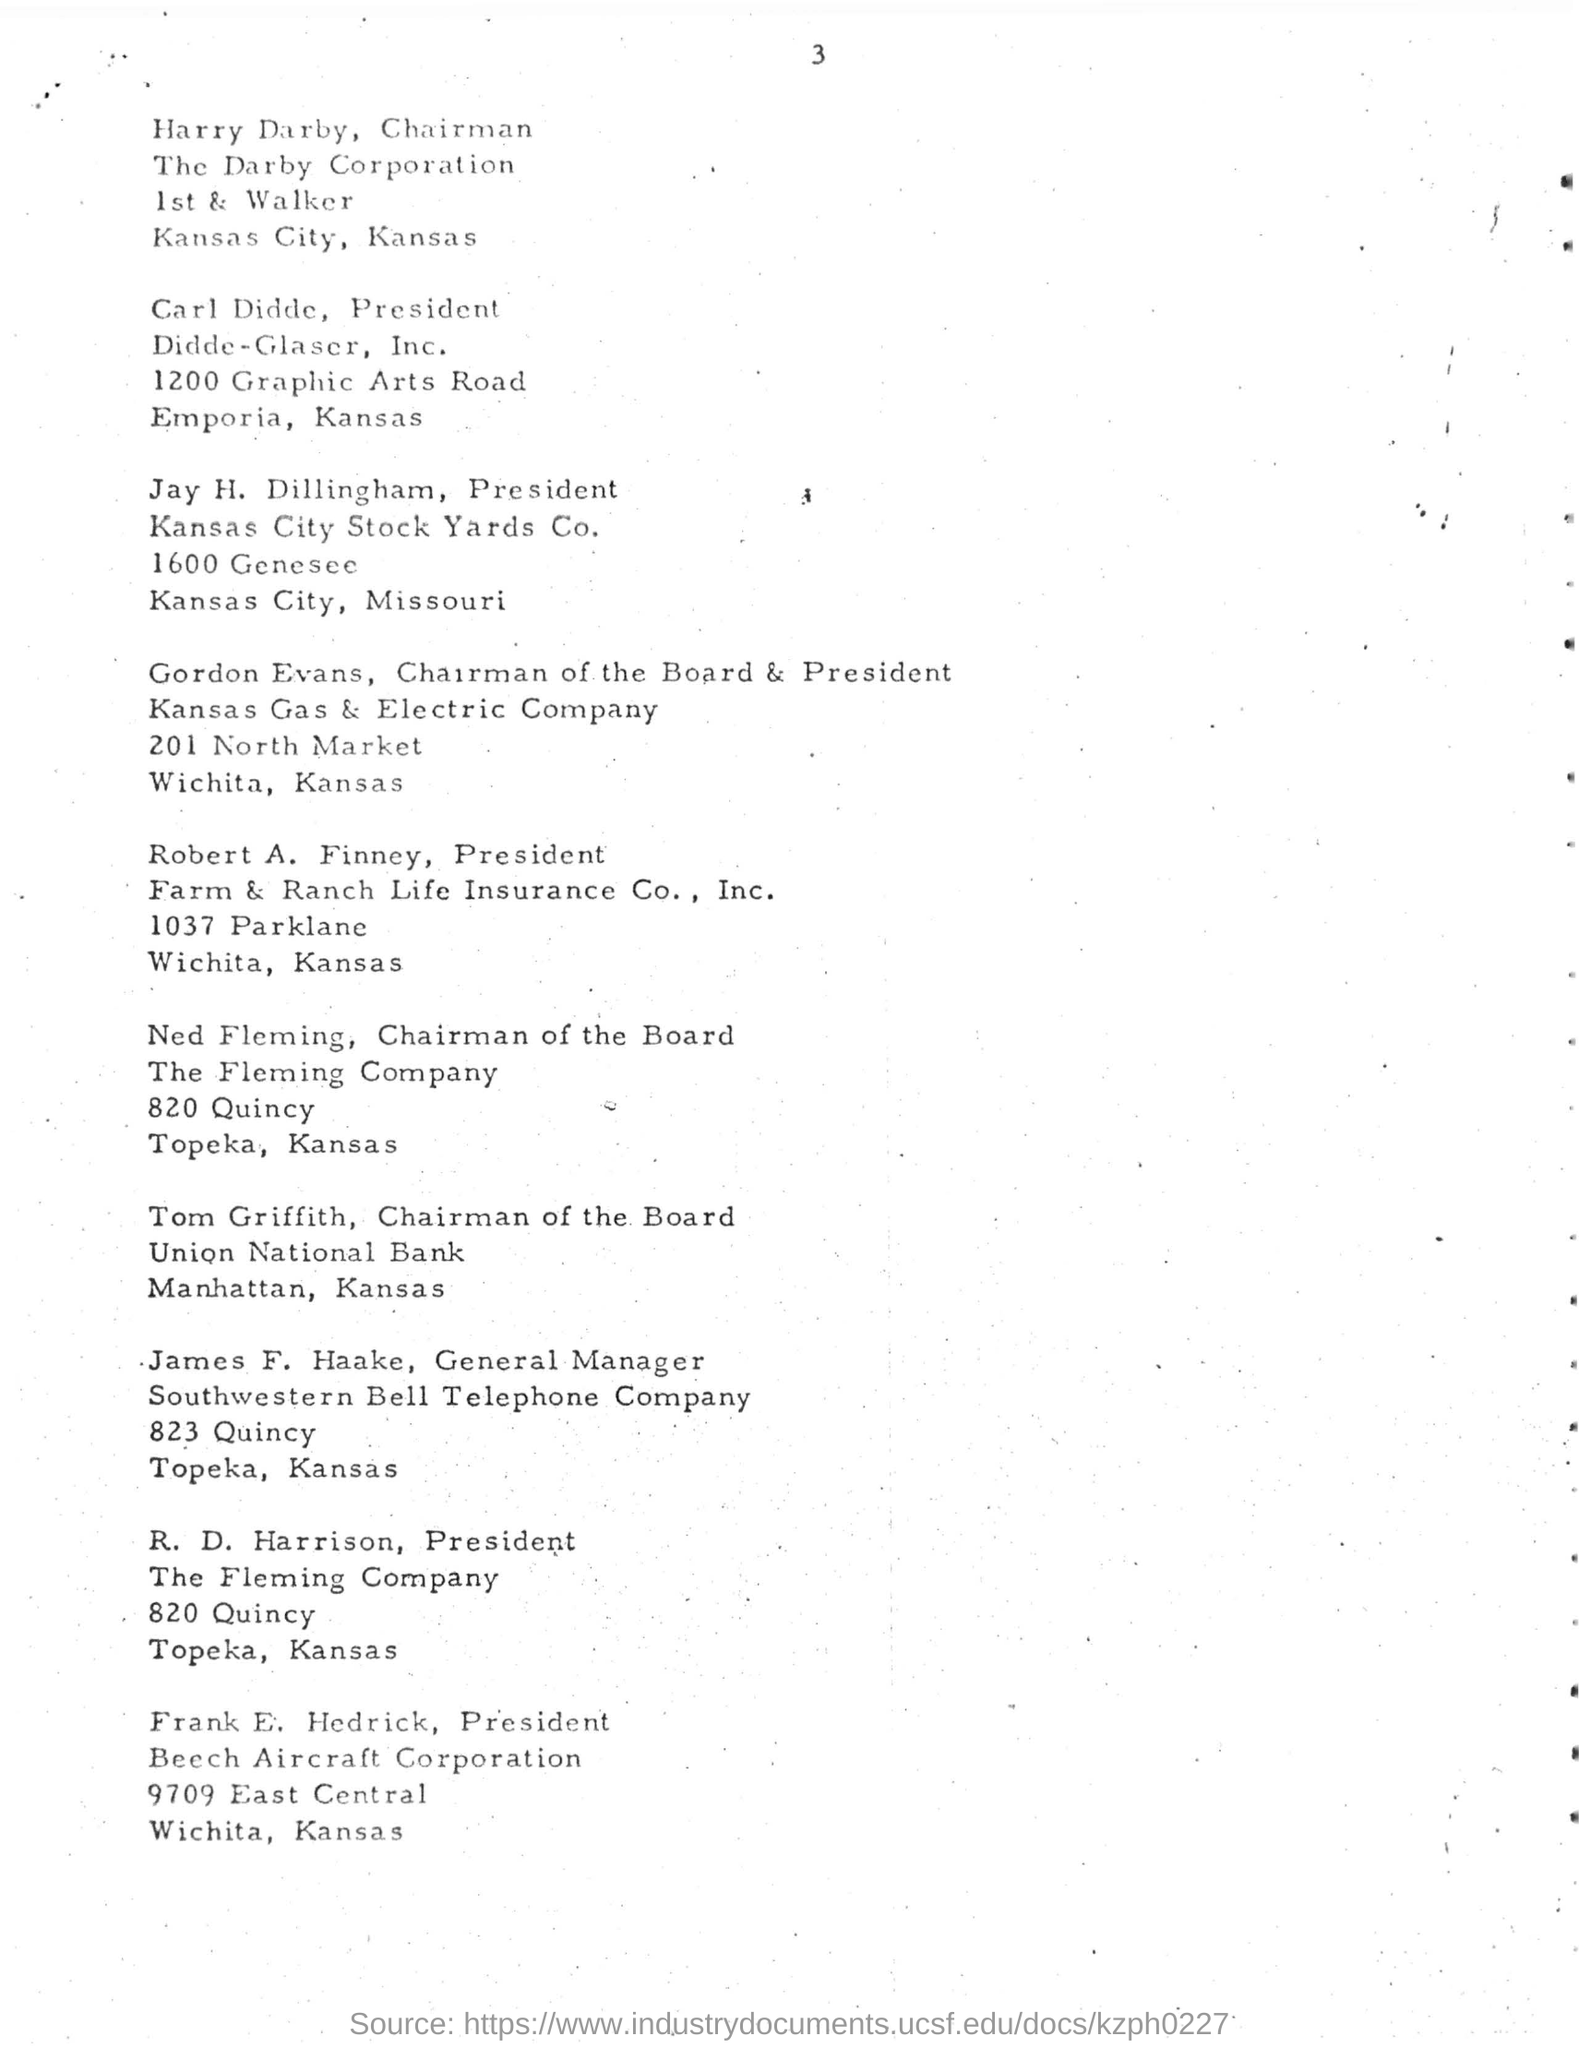Who is designated as the chairman for the darby corporation?
Your answer should be very brief. Harry Darby. In which city the darby corporation is situated?
Offer a terse response. Kansas City. Who is designated as president for the didde-glascr,inc.?
Offer a very short reply. Carl Didde. In which company jay h.dillingham are designated as president?
Ensure brevity in your answer.  Kansas City Stock Yards Co. In which company gordan evans, are designated as chariman of board & president?
Your answer should be compact. Kansas Gas & Electric Company. What is the designation of ned fleming in "the fleming company"?
Your answer should be very brief. Chairman of the Board. In which city "united national bank" is situated?
Provide a short and direct response. Manhattan. What is the name of telephone company?
Provide a succinct answer. Southwestern Bell. Who is designated as president in the fleming company?
Make the answer very short. R. D. Harrison. In which corporation frank e. hedrick is designated as president?
Provide a succinct answer. Beech Aircraft Corporation. 